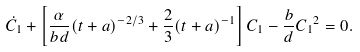<formula> <loc_0><loc_0><loc_500><loc_500>\dot { C _ { 1 } } + \left [ \frac { \alpha } { b d } ( t + a ) ^ { - 2 / 3 } + \frac { 2 } { 3 } ( t + a ) ^ { - 1 } \right ] C _ { 1 } - \frac { b } { d } { C _ { 1 } } ^ { 2 } = 0 .</formula> 